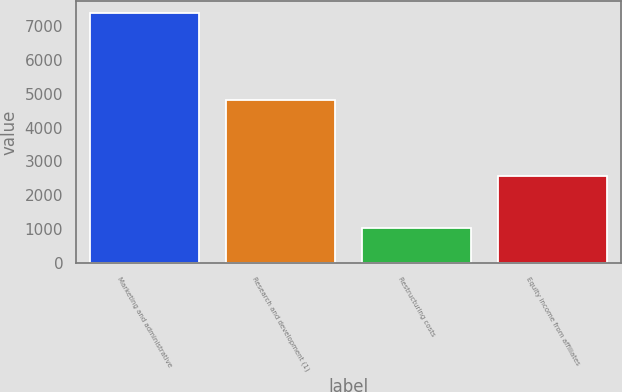<chart> <loc_0><loc_0><loc_500><loc_500><bar_chart><fcel>Marketing and administrative<fcel>Research and development (1)<fcel>Restructuring costs<fcel>Equity income from affiliates<nl><fcel>7377<fcel>4805<fcel>1033<fcel>2561<nl></chart> 